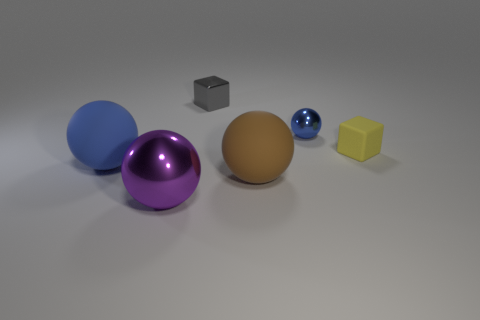Subtract 1 balls. How many balls are left? 3 Add 2 small yellow shiny spheres. How many objects exist? 8 Subtract all blocks. How many objects are left? 4 Subtract all purple balls. Subtract all red shiny cylinders. How many objects are left? 5 Add 3 small yellow rubber cubes. How many small yellow rubber cubes are left? 4 Add 5 tiny metallic objects. How many tiny metallic objects exist? 7 Subtract 1 yellow cubes. How many objects are left? 5 